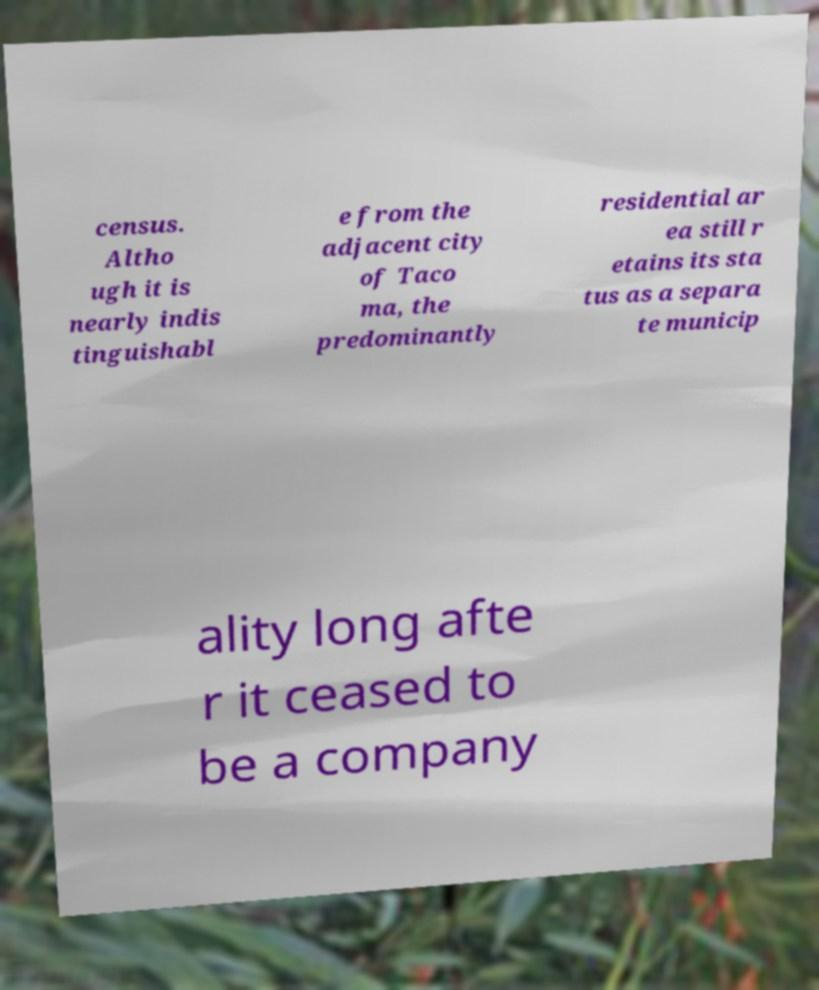Could you assist in decoding the text presented in this image and type it out clearly? census. Altho ugh it is nearly indis tinguishabl e from the adjacent city of Taco ma, the predominantly residential ar ea still r etains its sta tus as a separa te municip ality long afte r it ceased to be a company 